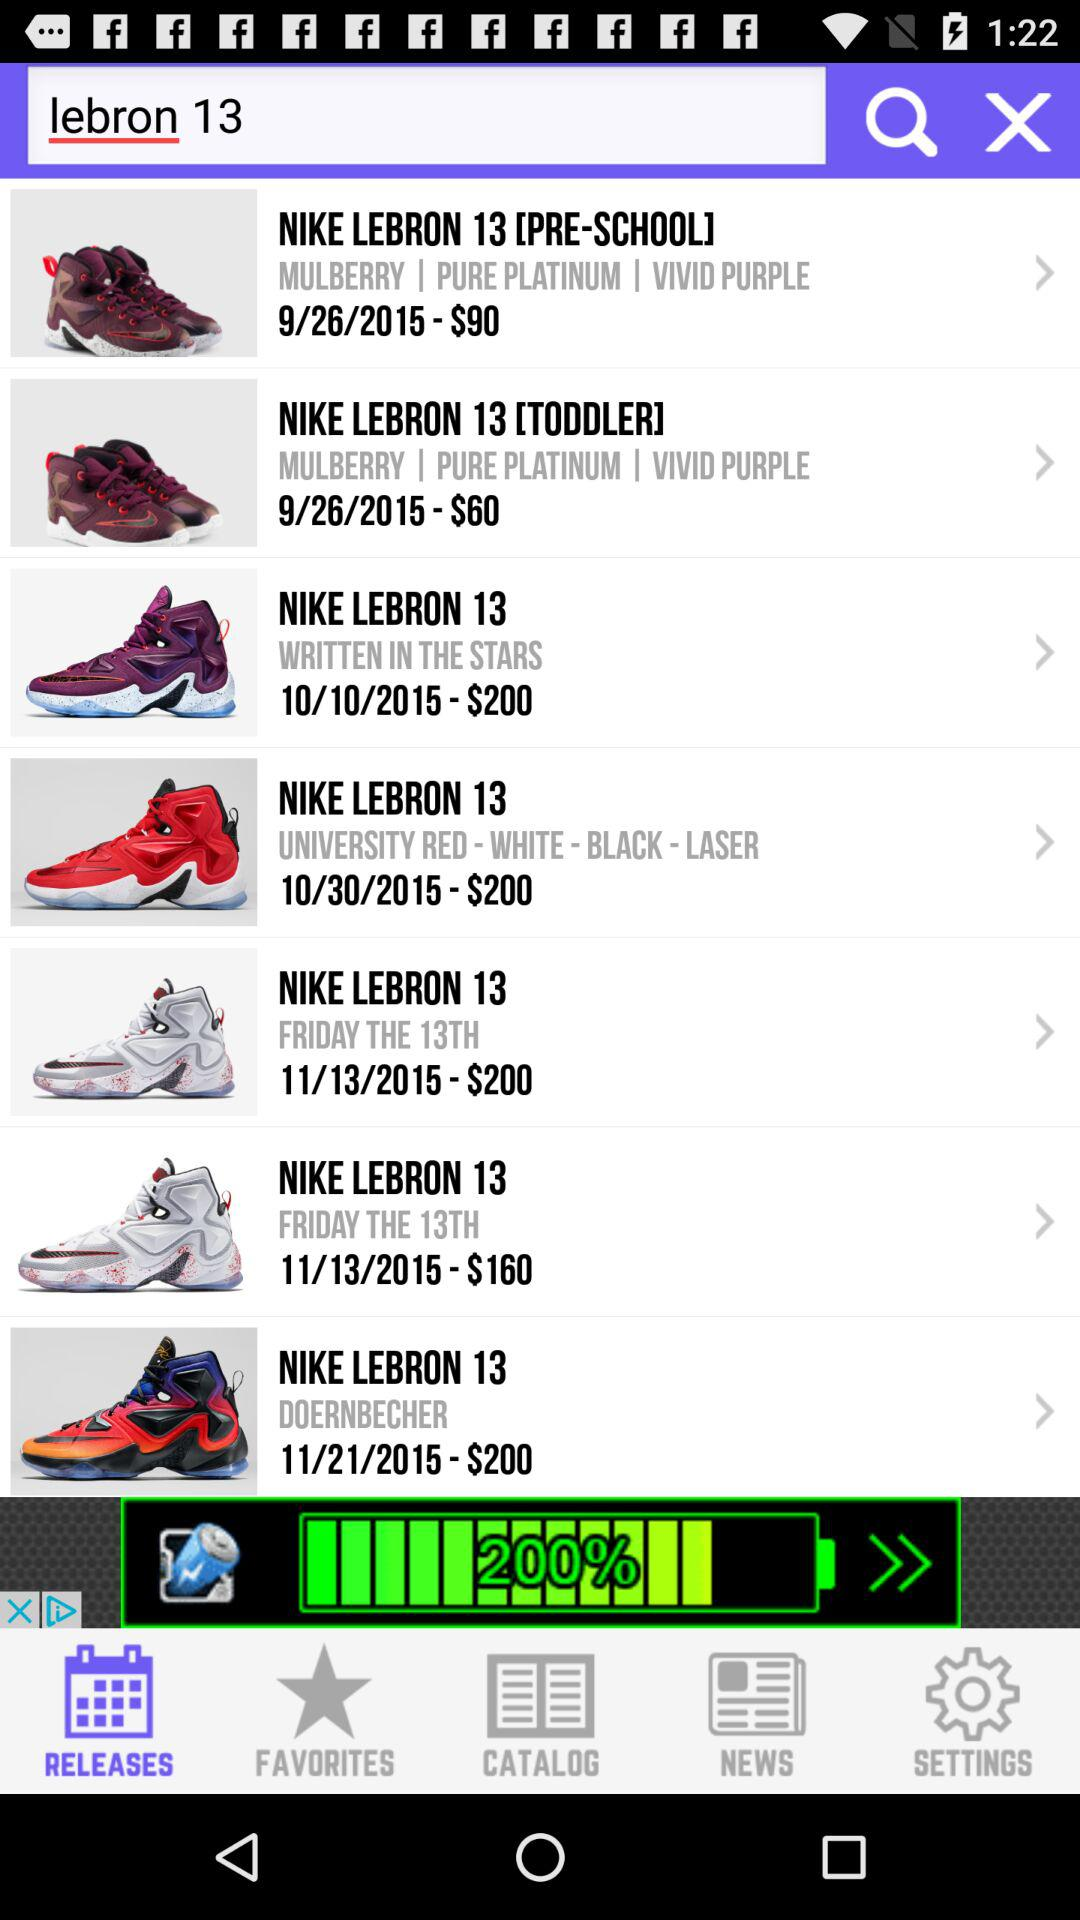What is the price of the "NIKE LEBRON 13 WRITTEN IN THE STARS"? The price of the "NIKE LEBRON 13 WRITTEN IN THE STARS" is $200. 